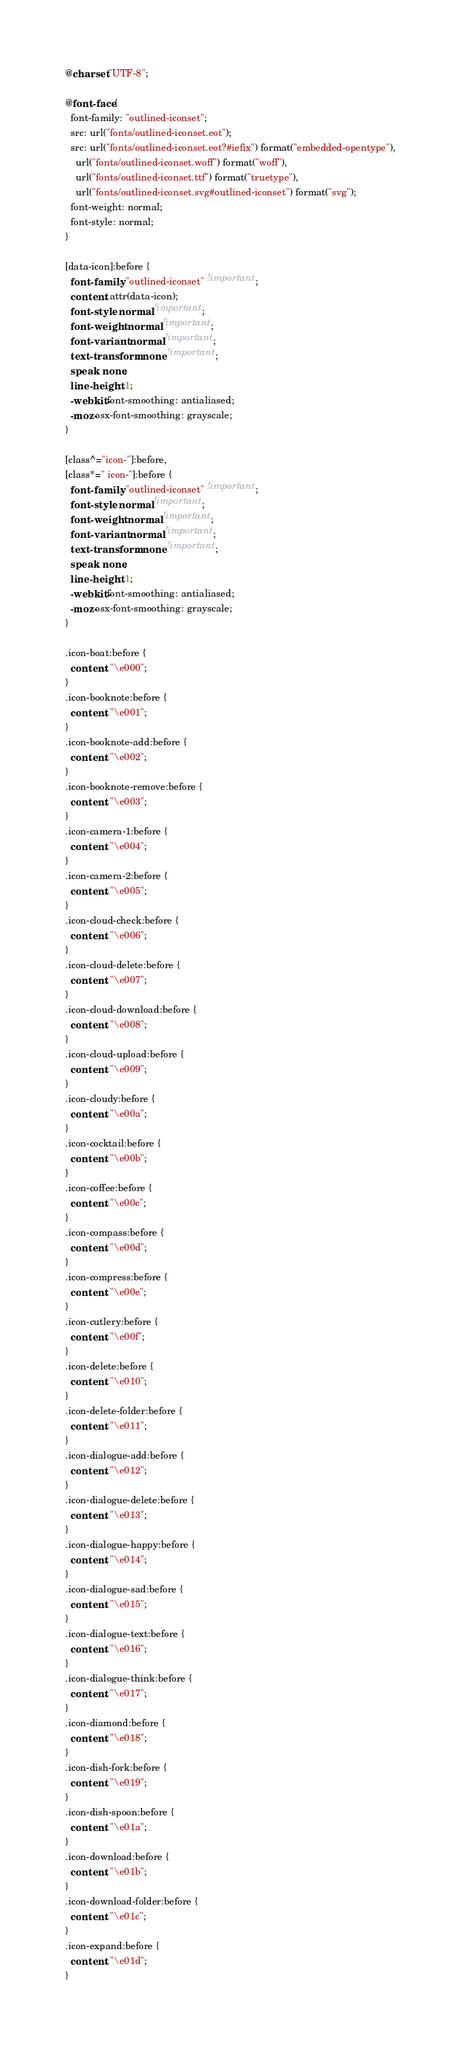Convert code to text. <code><loc_0><loc_0><loc_500><loc_500><_CSS_>@charset "UTF-8";

@font-face {
  font-family: "outlined-iconset";
  src: url("fonts/outlined-iconset.eot");
  src: url("fonts/outlined-iconset.eot?#iefix") format("embedded-opentype"),
    url("fonts/outlined-iconset.woff") format("woff"),
    url("fonts/outlined-iconset.ttf") format("truetype"),
    url("fonts/outlined-iconset.svg#outlined-iconset") format("svg");
  font-weight: normal;
  font-style: normal;
}

[data-icon]:before {
  font-family: "outlined-iconset" !important;
  content: attr(data-icon);
  font-style: normal !important;
  font-weight: normal !important;
  font-variant: normal !important;
  text-transform: none !important;
  speak: none;
  line-height: 1;
  -webkit-font-smoothing: antialiased;
  -moz-osx-font-smoothing: grayscale;
}

[class^="icon-"]:before,
[class*=" icon-"]:before {
  font-family: "outlined-iconset" !important;
  font-style: normal !important;
  font-weight: normal !important;
  font-variant: normal !important;
  text-transform: none !important;
  speak: none;
  line-height: 1;
  -webkit-font-smoothing: antialiased;
  -moz-osx-font-smoothing: grayscale;
}

.icon-boat:before {
  content: "\e000";
}
.icon-booknote:before {
  content: "\e001";
}
.icon-booknote-add:before {
  content: "\e002";
}
.icon-booknote-remove:before {
  content: "\e003";
}
.icon-camera-1:before {
  content: "\e004";
}
.icon-camera-2:before {
  content: "\e005";
}
.icon-cloud-check:before {
  content: "\e006";
}
.icon-cloud-delete:before {
  content: "\e007";
}
.icon-cloud-download:before {
  content: "\e008";
}
.icon-cloud-upload:before {
  content: "\e009";
}
.icon-cloudy:before {
  content: "\e00a";
}
.icon-cocktail:before {
  content: "\e00b";
}
.icon-coffee:before {
  content: "\e00c";
}
.icon-compass:before {
  content: "\e00d";
}
.icon-compress:before {
  content: "\e00e";
}
.icon-cutlery:before {
  content: "\e00f";
}
.icon-delete:before {
  content: "\e010";
}
.icon-delete-folder:before {
  content: "\e011";
}
.icon-dialogue-add:before {
  content: "\e012";
}
.icon-dialogue-delete:before {
  content: "\e013";
}
.icon-dialogue-happy:before {
  content: "\e014";
}
.icon-dialogue-sad:before {
  content: "\e015";
}
.icon-dialogue-text:before {
  content: "\e016";
}
.icon-dialogue-think:before {
  content: "\e017";
}
.icon-diamond:before {
  content: "\e018";
}
.icon-dish-fork:before {
  content: "\e019";
}
.icon-dish-spoon:before {
  content: "\e01a";
}
.icon-download:before {
  content: "\e01b";
}
.icon-download-folder:before {
  content: "\e01c";
}
.icon-expand:before {
  content: "\e01d";
}</code> 